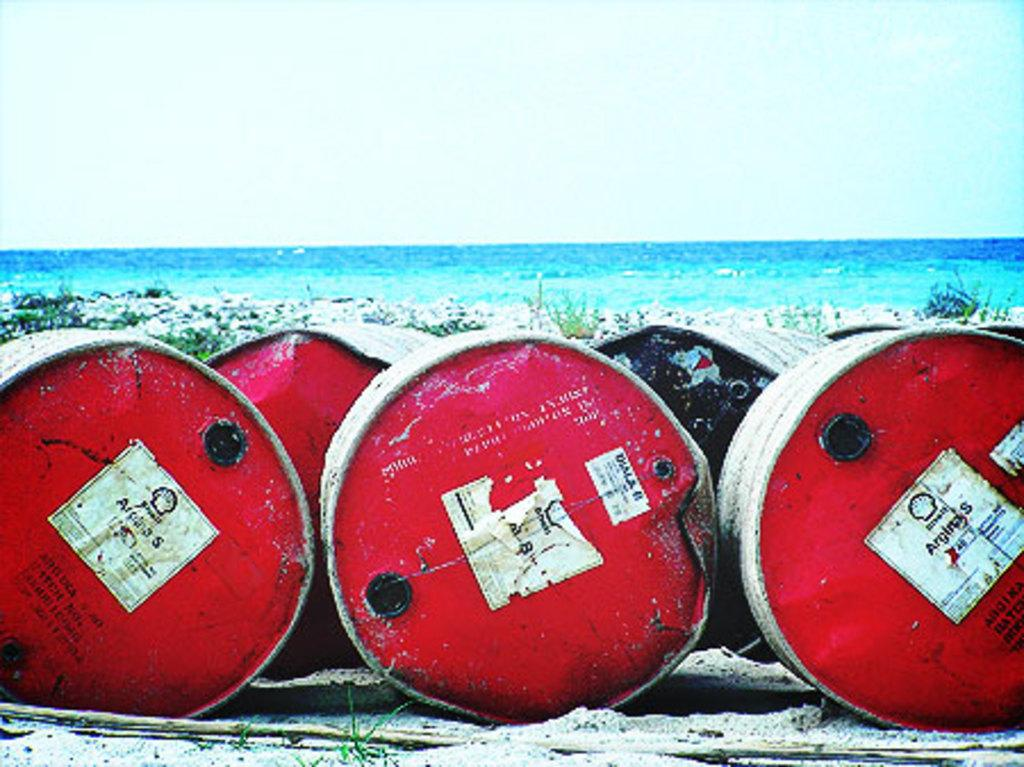What objects are present in the image? There are barrels in the image. What can be seen in the background of the image? There is water visible in the background of the image. What type of vegetation is present in the image? There is grass in the image. What is visible at the top of the image? The sky is visible at the top of the image. What type of button can be seen on the ground in the image? There is no button present on the ground in the image. 